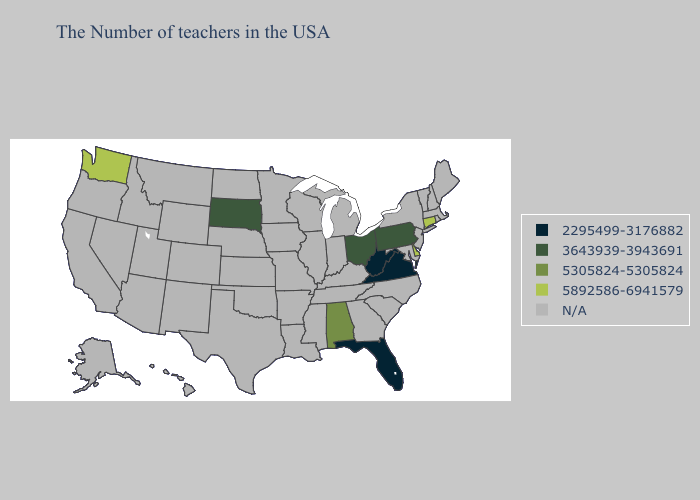What is the value of Wisconsin?
Concise answer only. N/A. What is the lowest value in the USA?
Keep it brief. 2295499-3176882. What is the value of Connecticut?
Be succinct. 5892586-6941579. How many symbols are there in the legend?
Quick response, please. 5. Does the first symbol in the legend represent the smallest category?
Give a very brief answer. Yes. What is the value of New York?
Write a very short answer. N/A. What is the value of Georgia?
Answer briefly. N/A. Does Ohio have the highest value in the USA?
Answer briefly. No. What is the value of Wyoming?
Keep it brief. N/A. What is the highest value in states that border Georgia?
Quick response, please. 5305824-5305824. What is the lowest value in states that border North Carolina?
Write a very short answer. 2295499-3176882. 